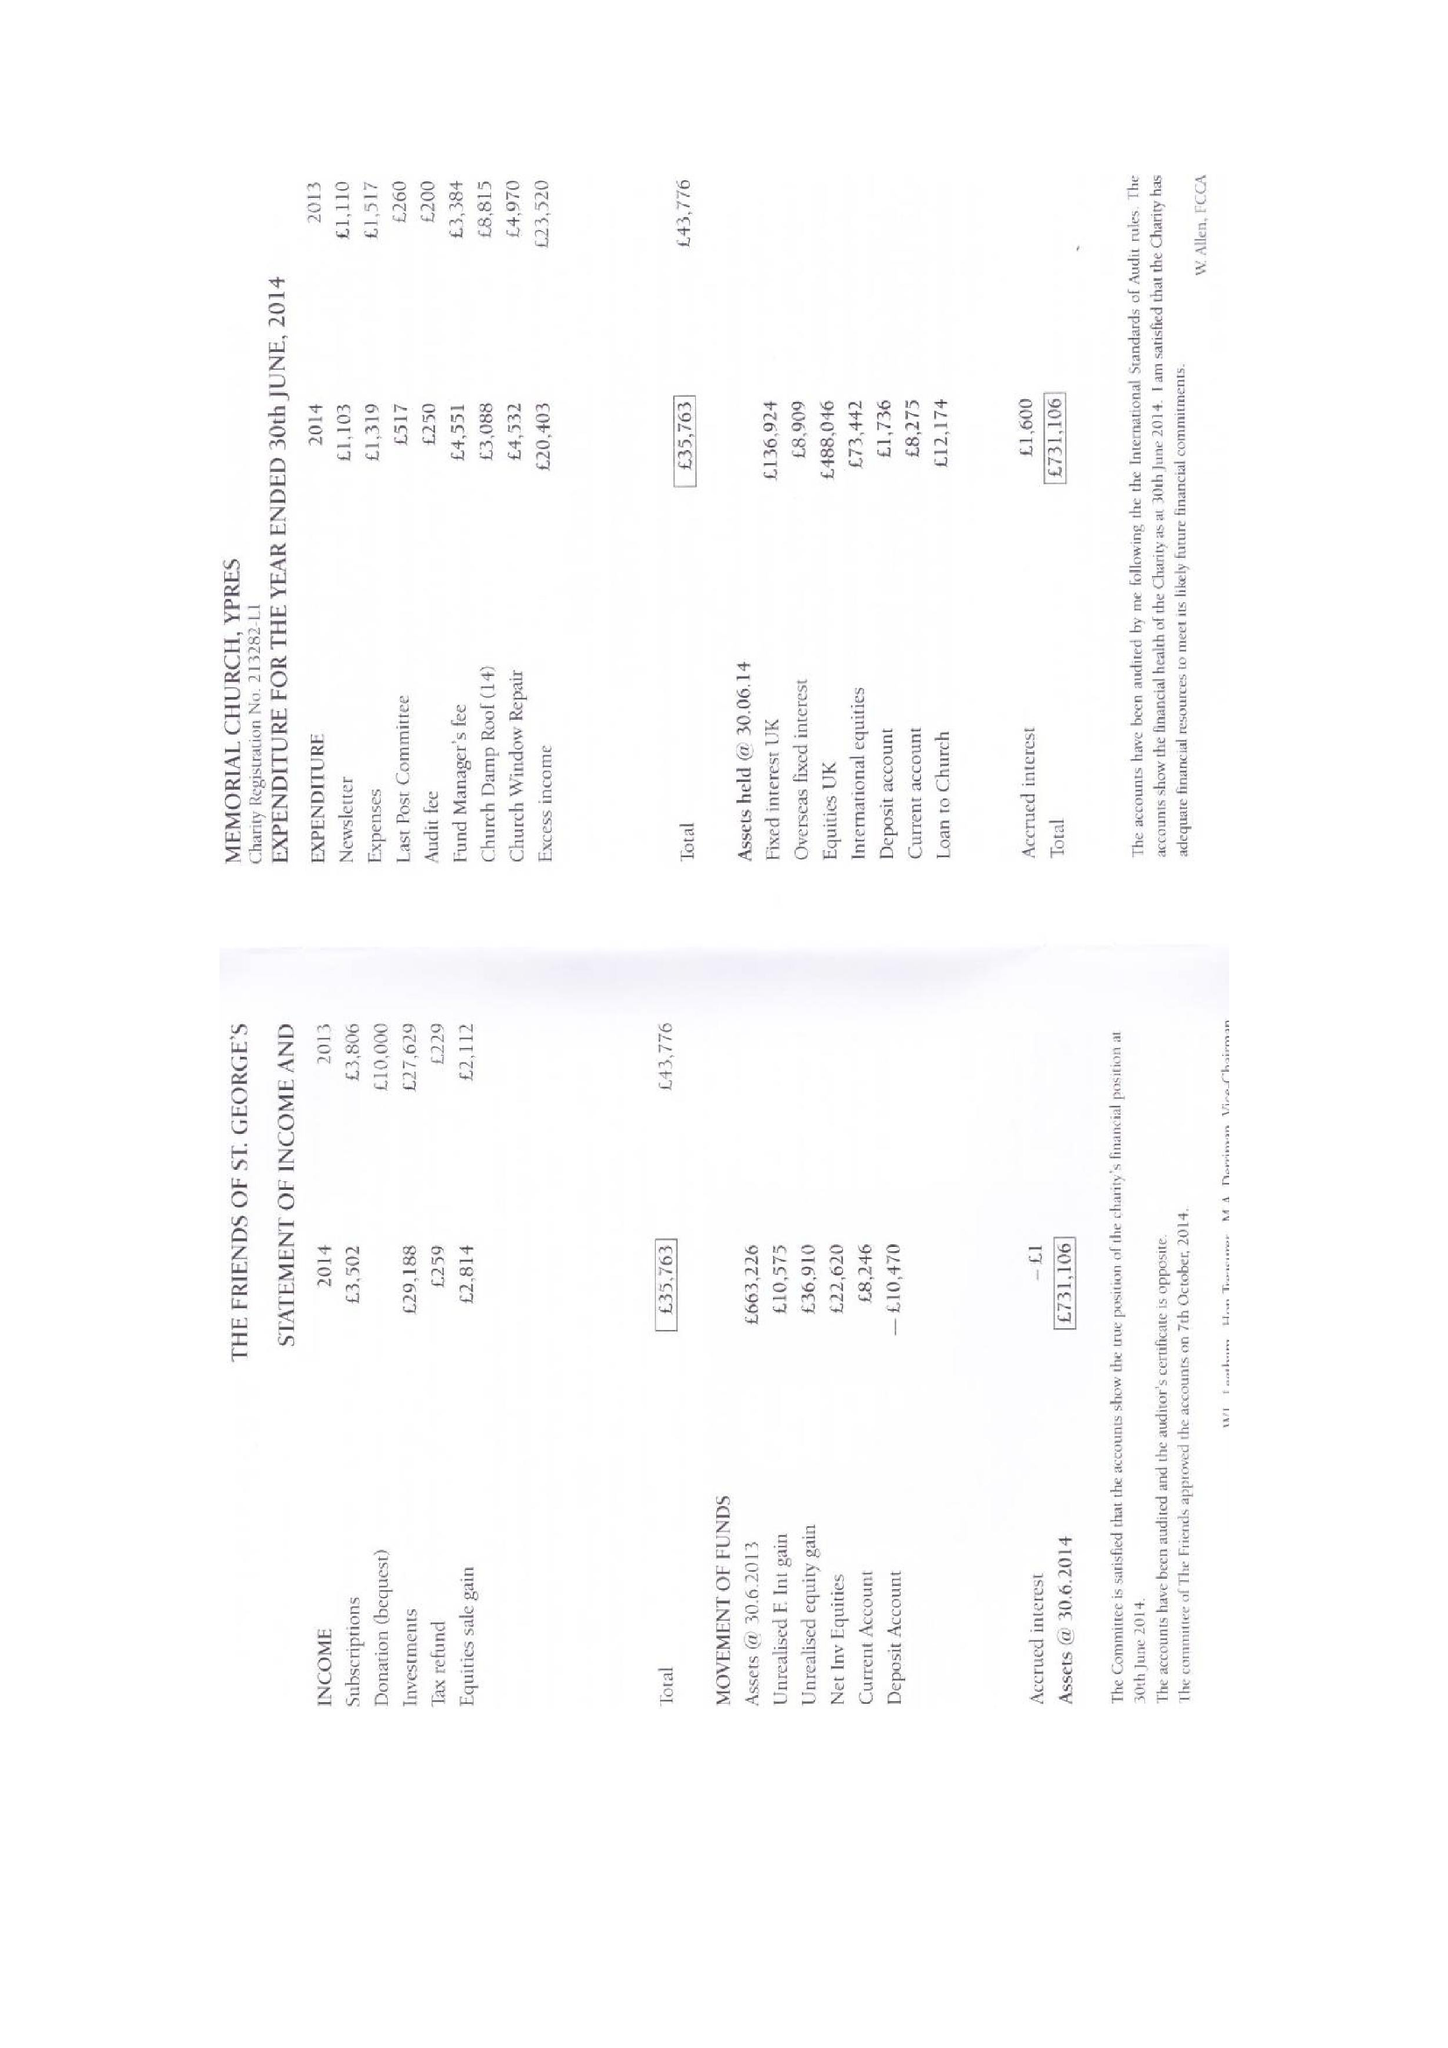What is the value for the report_date?
Answer the question using a single word or phrase. 2014-06-30 